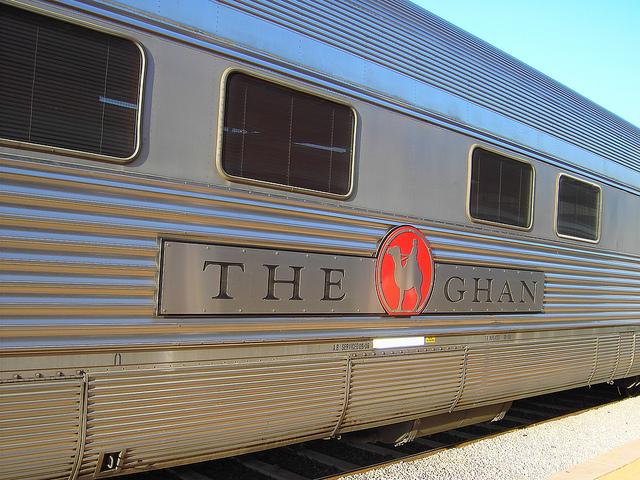What train line does the train belong to?
Be succinct. Ghan. Where is the train at?
Answer briefly. Station. Where does this train run?
Short answer required. Ghan. What is the name on the train?
Short answer required. Ghan. 